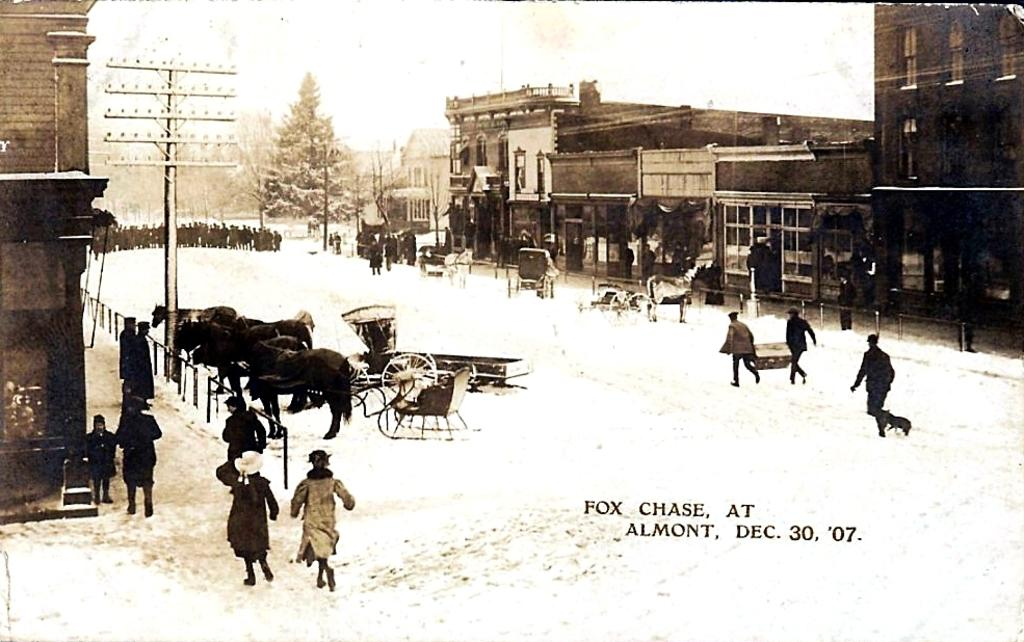What is happening on the road in the image? There is a crowd on the road in the image. What mode of transportation can be seen in the image? Horse carts are present in the image. What type of barrier is visible in the image? There is a fence in the image. What structures are present in the image that provide light? Light poles are present in the image. What type of buildings can be seen in the image? There are buildings in the image. What type of vegetation is visible in the image? There are trees in the image. What type of text is present in the image? There is text in the image. What part of the natural environment is visible in the image? The sky is visible in the image. Can you tell me what the baby is arguing about in the image? There is no baby or argument present in the image. What type of advertisement can be seen on the buildings in the image? There is no advertisement visible on the buildings in the image. 